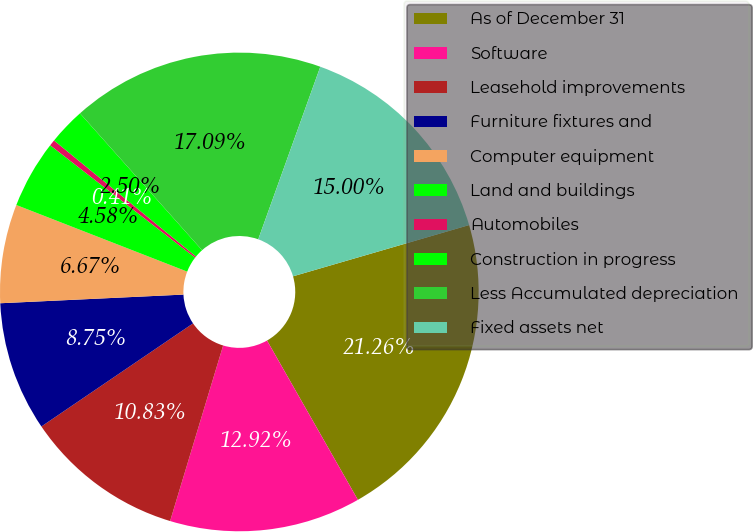<chart> <loc_0><loc_0><loc_500><loc_500><pie_chart><fcel>As of December 31<fcel>Software<fcel>Leasehold improvements<fcel>Furniture fixtures and<fcel>Computer equipment<fcel>Land and buildings<fcel>Automobiles<fcel>Construction in progress<fcel>Less Accumulated depreciation<fcel>Fixed assets net<nl><fcel>21.26%<fcel>12.92%<fcel>10.83%<fcel>8.75%<fcel>6.67%<fcel>4.58%<fcel>0.41%<fcel>2.5%<fcel>17.09%<fcel>15.0%<nl></chart> 